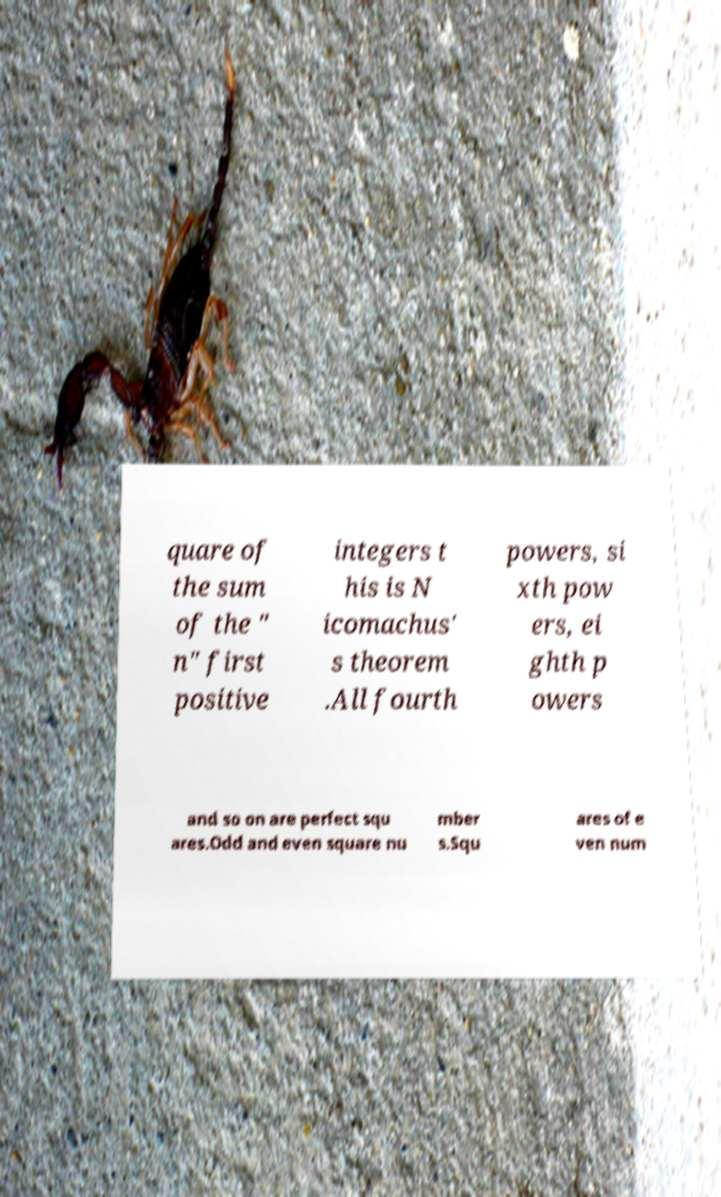There's text embedded in this image that I need extracted. Can you transcribe it verbatim? quare of the sum of the " n" first positive integers t his is N icomachus' s theorem .All fourth powers, si xth pow ers, ei ghth p owers and so on are perfect squ ares.Odd and even square nu mber s.Squ ares of e ven num 